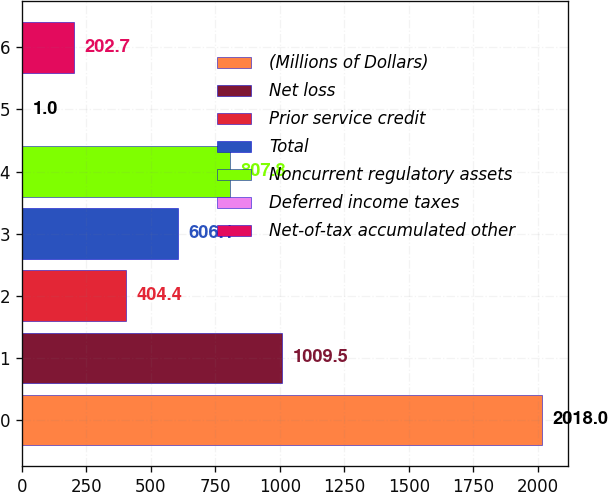Convert chart to OTSL. <chart><loc_0><loc_0><loc_500><loc_500><bar_chart><fcel>(Millions of Dollars)<fcel>Net loss<fcel>Prior service credit<fcel>Total<fcel>Noncurrent regulatory assets<fcel>Deferred income taxes<fcel>Net-of-tax accumulated other<nl><fcel>2018<fcel>1009.5<fcel>404.4<fcel>606.1<fcel>807.8<fcel>1<fcel>202.7<nl></chart> 